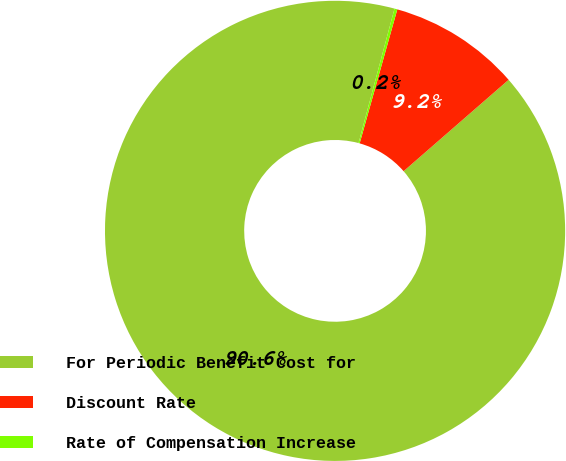<chart> <loc_0><loc_0><loc_500><loc_500><pie_chart><fcel>For Periodic Benefit Cost for<fcel>Discount Rate<fcel>Rate of Compensation Increase<nl><fcel>90.56%<fcel>9.24%<fcel>0.2%<nl></chart> 